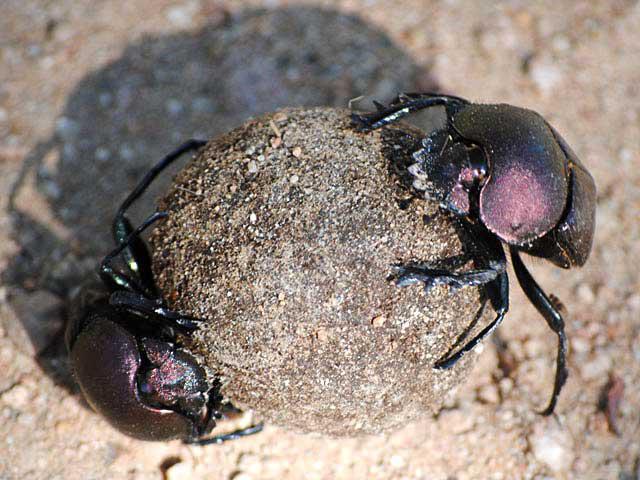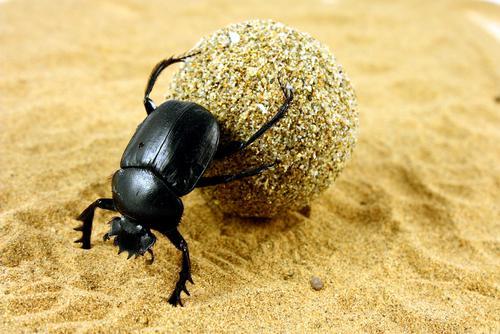The first image is the image on the left, the second image is the image on the right. Evaluate the accuracy of this statement regarding the images: "All of the bugs are greenish in color.". Is it true? Answer yes or no. No. The first image is the image on the left, the second image is the image on the right. Examine the images to the left and right. Is the description "An image depicts a beetle with head facing leftward, a green iridescent hind segment, and reddish iridescence above that." accurate? Answer yes or no. No. 